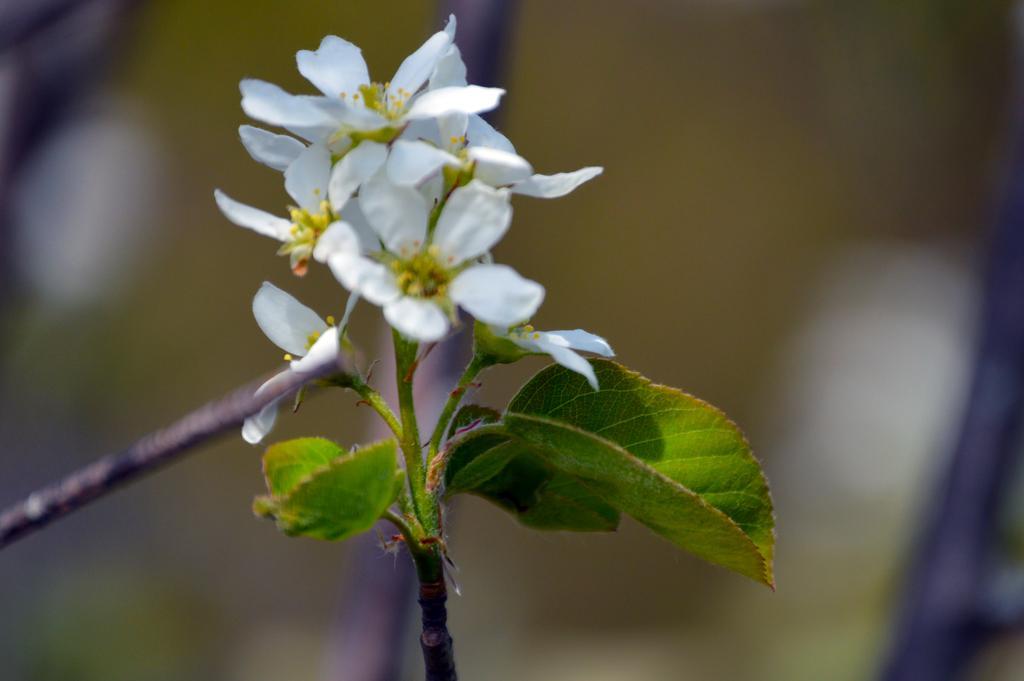Please provide a concise description of this image. In this picture there is a plant, to the plant there are leaves and flowers. The background is blurred. 